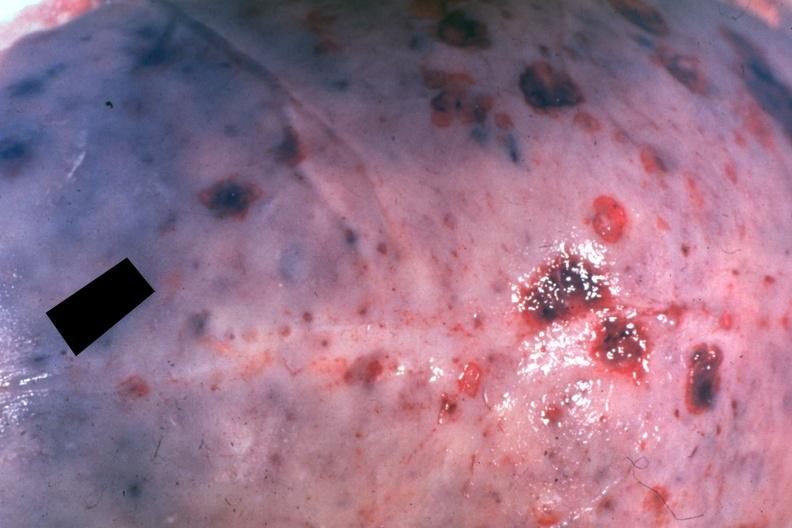what is present?
Answer the question using a single word or phrase. Bone, calvarium 